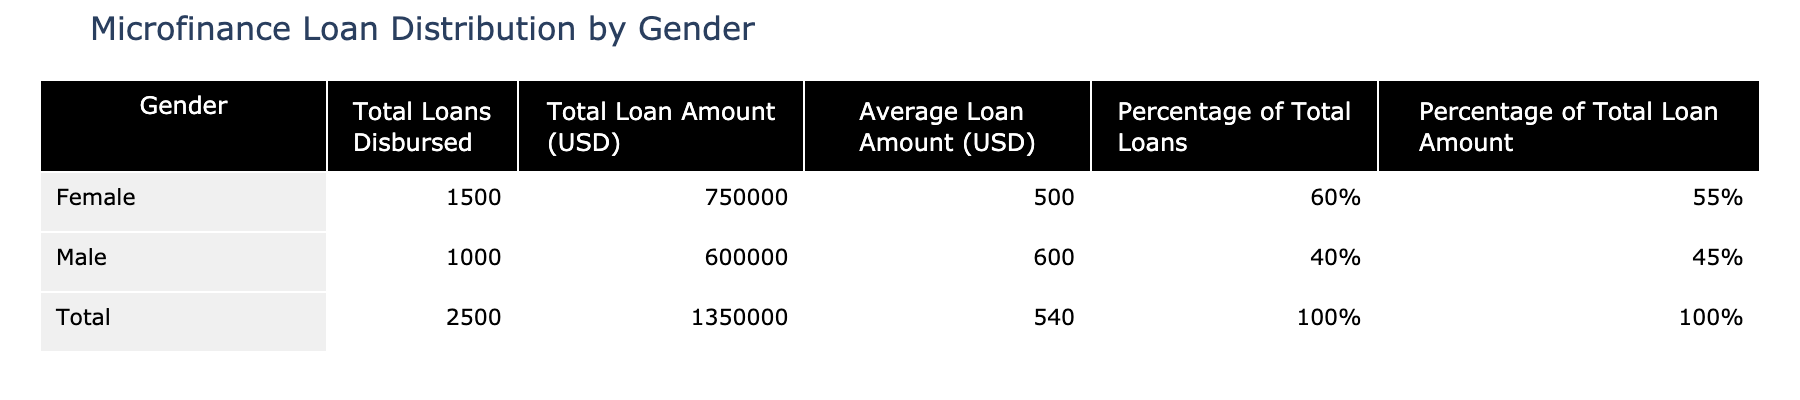What is the total number of loans disbursed to females? According to the table, the total loans disbursed to females is explicitly stated as 1500.
Answer: 1500 What is the total loan amount disbursed to males? The table shows that the total loan amount disbursed to males is 600,000 USD.
Answer: 600,000 USD What percentage of total loans was disbursed to females? The table provides the percentage of total loans disbursed to females as 60%.
Answer: 60% What is the average loan amount for males? The average loan amount for males is provided in the table as 600 USD.
Answer: 600 USD How many more loans were disbursed to females than to males? To find the difference, subtract the number of loans disbursed to males (1000) from those disbursed to females (1500): 1500 - 1000 = 500.
Answer: 500 What is the total loan amount for both genders combined? The total loan amount for both genders is directly stated in the table as 1,350,000 USD.
Answer: 1,350,000 USD What is the average loan amount for all loans disbursed? The average loan amount for all loans is given as 540 USD, which is the total loan amount (1,350,000 USD) divided by the total number of loans (2500).
Answer: 540 USD True or False: More than half of the total loan amount was disbursed to females. The table states that females received 55% of the total loan amount, which is less than half (50%). Therefore, the statement is false.
Answer: False What is the difference between the average loan amounts for females and males? Subtract the average loan amount for females (500 USD) from that for males (600 USD): 600 - 500 = 100 USD.
Answer: 100 USD If the total number of loans increased to 3000 while maintaining the same distribution ratio, how many loans would go to females? Currently, females receive 60% of the loans. If the total loans are 3000, multiply 3000 by 0.6 to get the number of loans for females: 3000 * 0.6 = 1800 loans.
Answer: 1800 loans 